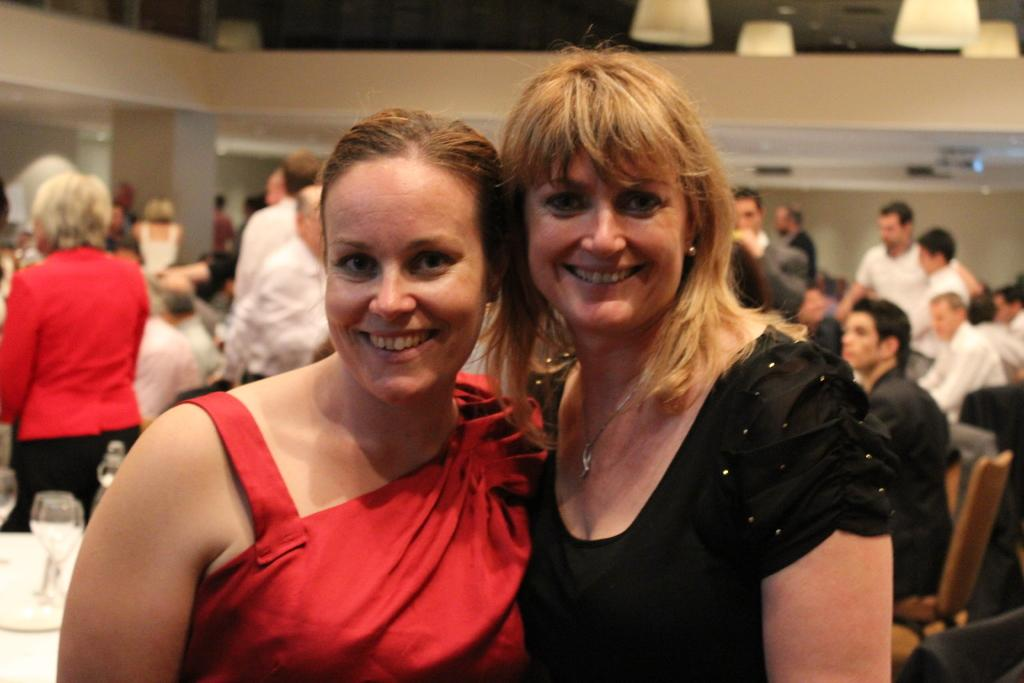What can be seen in the image? There are people, chairs, tables, glasses, lights, a projector, and a pillar in the image. What are the people in the image doing? In the front of the image, two people are smiling. Where are the glasses located in the image? The glasses are on the table. How many pigs are present in the image? There are no pigs present in the image. What type of cable is connected to the projector in the image? There is no cable connected to the projector in the image. Can you tell me the color of the needle in the image? There is no needle present in the image. 